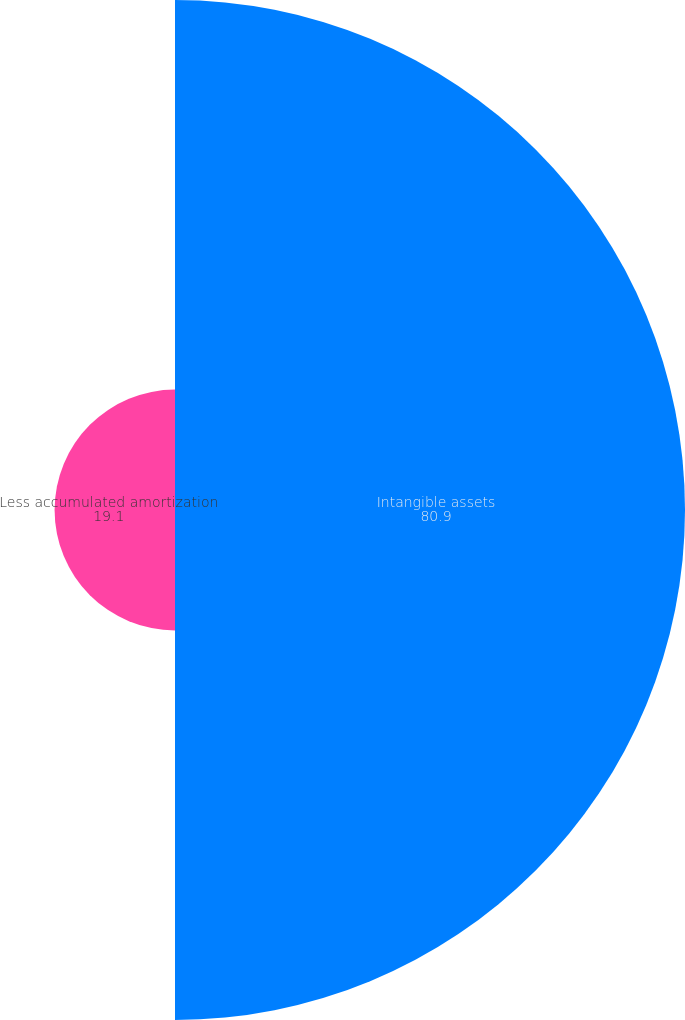<chart> <loc_0><loc_0><loc_500><loc_500><pie_chart><fcel>Intangible assets<fcel>Less accumulated amortization<nl><fcel>80.9%<fcel>19.1%<nl></chart> 